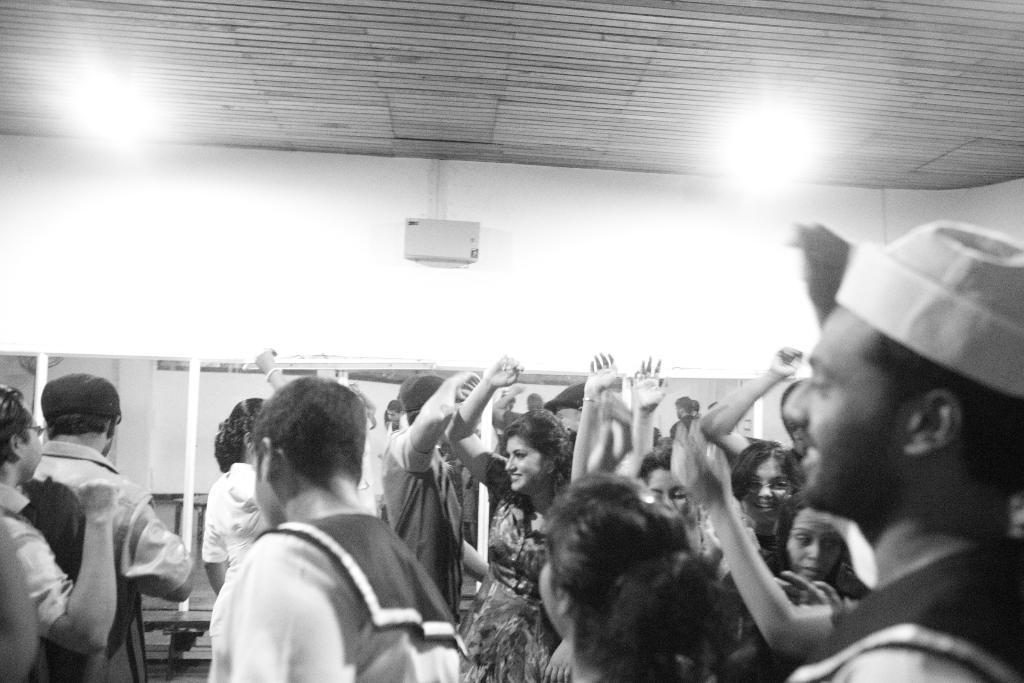In one or two sentences, can you explain what this image depicts? It is a black and white image. In this image there are people. Behind them there are a few objects. In the background of the image there is a wall. On top of the image there are lights. 